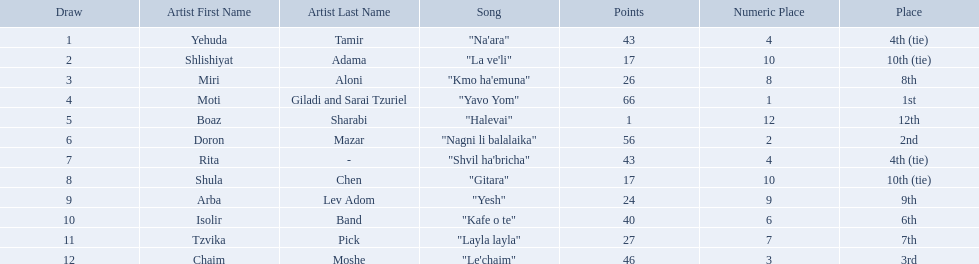What are the points in the competition? 43, 17, 26, 66, 1, 56, 43, 17, 24, 40, 27, 46. What is the lowest points? 1. What artist received these points? Boaz Sharabi. What is the place of the contestant who received only 1 point? 12th. What is the name of the artist listed in the previous question? Boaz Sharabi. Who are all of the artists? Yehuda Tamir, Shlishiyat Adama, Miri Aloni, Moti Giladi and Sarai Tzuriel, Boaz Sharabi, Doron Mazar, Rita, Shula Chen, Arba Lev Adom, Isolir Band, Tzvika Pick, Chaim Moshe. How many points did each score? 43, 17, 26, 66, 1, 56, 43, 17, 24, 40, 27, 46. And which artist had the least amount of points? Boaz Sharabi. 